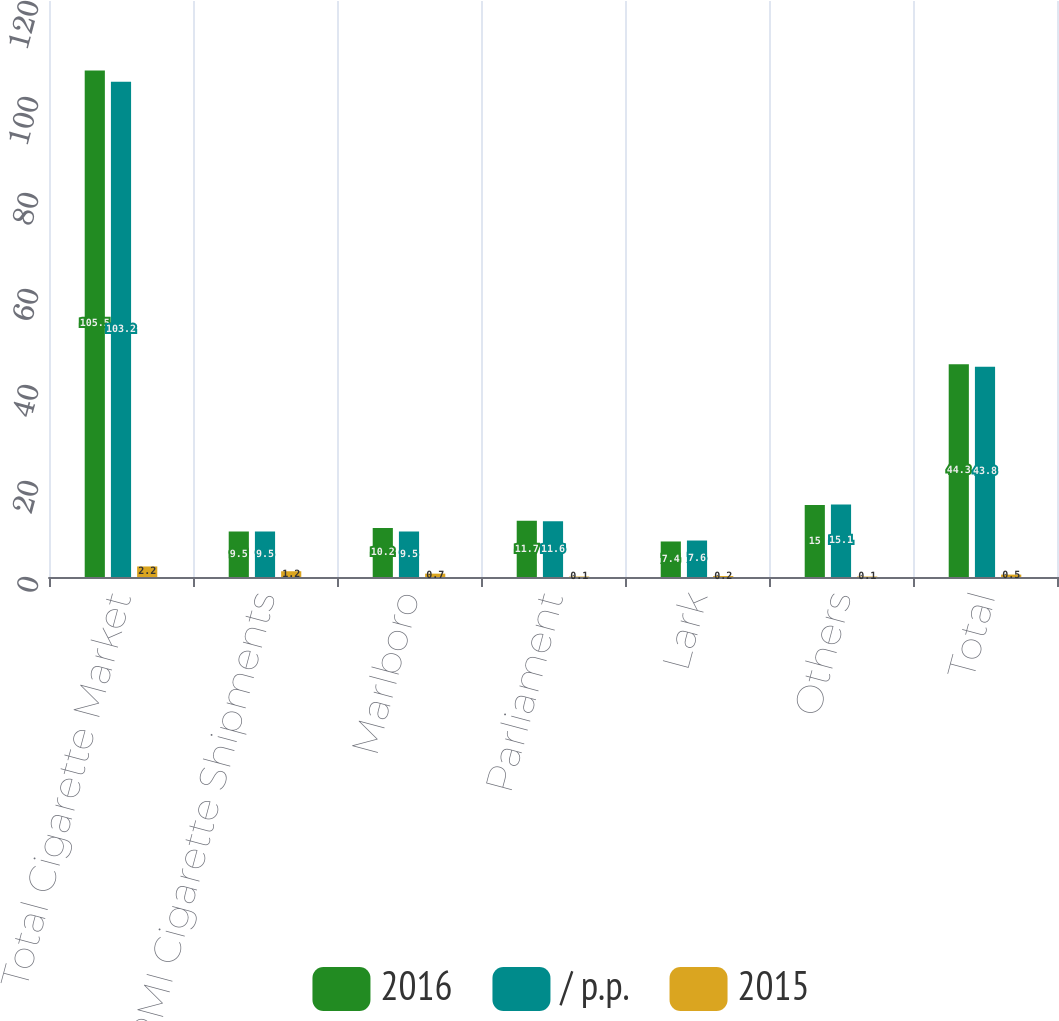Convert chart to OTSL. <chart><loc_0><loc_0><loc_500><loc_500><stacked_bar_chart><ecel><fcel>Total Cigarette Market<fcel>PMI Cigarette Shipments<fcel>Marlboro<fcel>Parliament<fcel>Lark<fcel>Others<fcel>Total<nl><fcel>2016<fcel>105.5<fcel>9.5<fcel>10.2<fcel>11.7<fcel>7.4<fcel>15<fcel>44.3<nl><fcel>/ p.p.<fcel>103.2<fcel>9.5<fcel>9.5<fcel>11.6<fcel>7.6<fcel>15.1<fcel>43.8<nl><fcel>2015<fcel>2.2<fcel>1.2<fcel>0.7<fcel>0.1<fcel>0.2<fcel>0.1<fcel>0.5<nl></chart> 